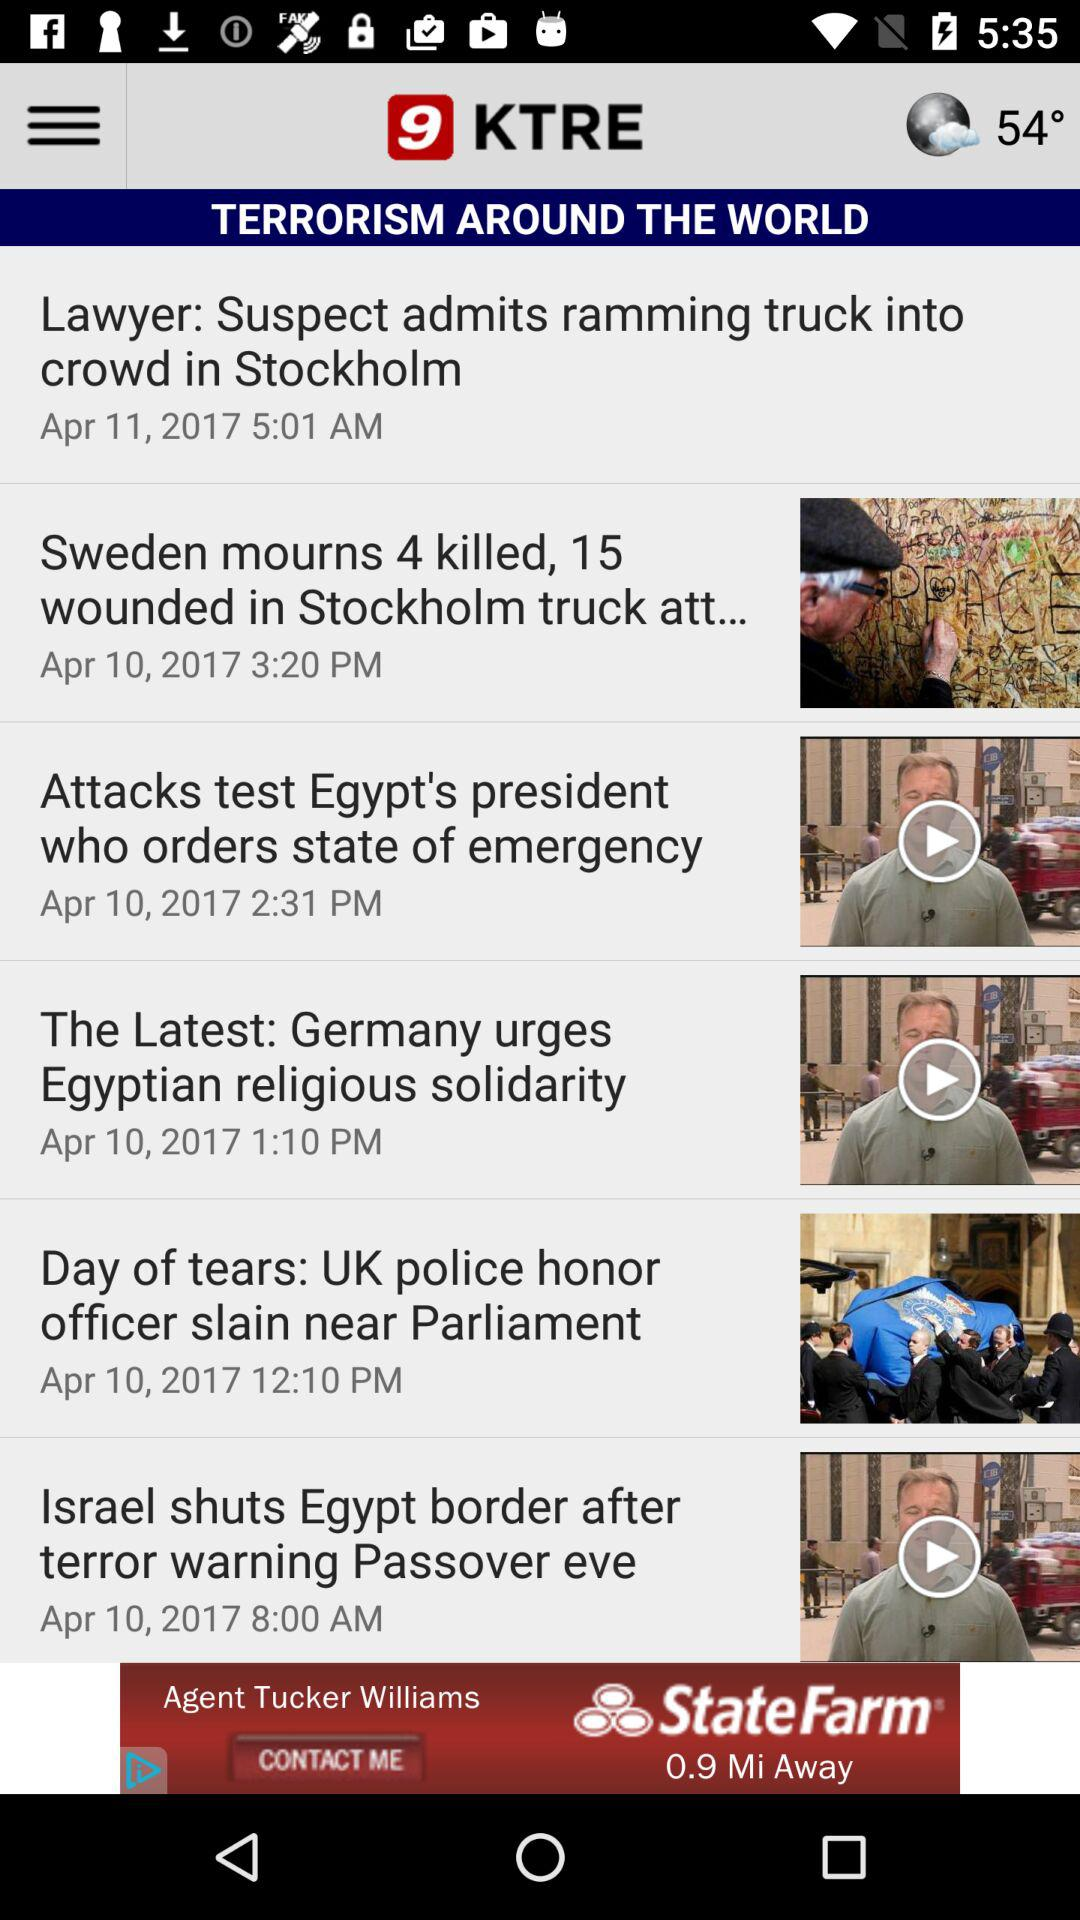What is the temperature? The temperature is 54°. 